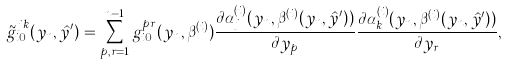Convert formula to latex. <formula><loc_0><loc_0><loc_500><loc_500>\tilde { g } _ { i 0 } ^ { j k } ( y _ { n } , \hat { y } ^ { \prime } ) = \sum _ { p , r = 1 } ^ { n - 1 } g _ { i 0 } ^ { p r } ( y _ { n } , \beta ^ { ( i ) } ) \frac { \partial \alpha _ { j } ^ { ( i ) } ( y _ { n } , \beta ^ { ( i ) } ( y _ { n } , \hat { y } ^ { \prime } ) ) } { \partial y _ { p } } \frac { \partial \alpha _ { k } ^ { ( i ) } ( y _ { n } , \beta ^ { ( i ) } ( y _ { n } , \hat { y } ^ { \prime } ) ) } { \partial y _ { r } } ,</formula> 